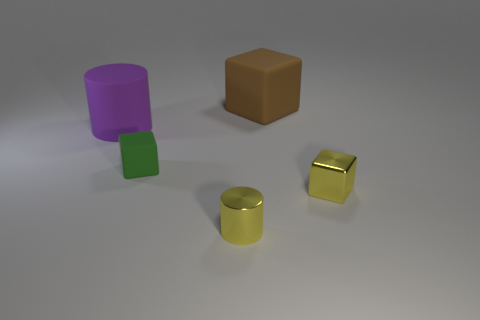Subtract all matte cubes. How many cubes are left? 1 Add 5 small green things. How many objects exist? 10 Subtract all brown rubber balls. Subtract all tiny matte things. How many objects are left? 4 Add 2 brown blocks. How many brown blocks are left? 3 Add 3 large purple cylinders. How many large purple cylinders exist? 4 Subtract 0 yellow balls. How many objects are left? 5 Subtract all cubes. How many objects are left? 2 